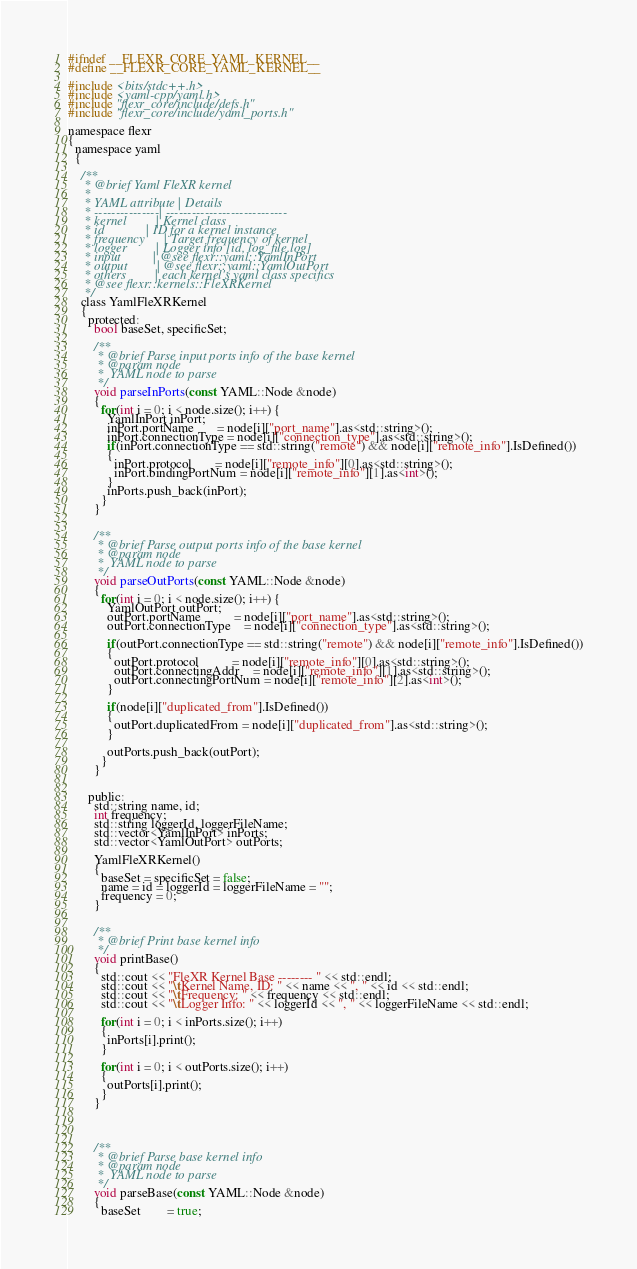<code> <loc_0><loc_0><loc_500><loc_500><_C_>#ifndef __FLEXR_CORE_YAML_KERNEL__
#define __FLEXR_CORE_YAML_KERNEL__

#include <bits/stdc++.h>
#include <yaml-cpp/yaml.h>
#include "flexr_core/include/defs.h"
#include "flexr_core/include/yaml_ports.h"

namespace flexr
{
  namespace yaml
  {

    /**
     * @brief Yaml FleXR kernel
     *
     * YAML attribute | Details
     * ---------------| ----------------------------
     * kernel         | Kernel class
     * id             | ID for a kernel instance
     * frequency      | Target frequency of kernel
     * logger         | Logger info [id, log_file.log]
     * input          | @see flexr::yaml::YamlInPort
     * output         | @see flexr::yaml::YamlOutPort
     * others         | each kernel's yaml class specifics
     * @see flexr::kernels::FleXRKernel
     */
    class YamlFleXRKernel
    {
      protected:
        bool baseSet, specificSet;

        /**
         * @brief Parse input ports info of the base kernel
         * @param node
         *  YAML node to parse
         */
        void parseInPorts(const YAML::Node &node)
        {
          for(int i = 0; i < node.size(); i++) {
            YamlInPort inPort;
            inPort.portName       = node[i]["port_name"].as<std::string>();
            inPort.connectionType = node[i]["connection_type"].as<std::string>();
            if(inPort.connectionType == std::string("remote") && node[i]["remote_info"].IsDefined())
            {
              inPort.protocol       = node[i]["remote_info"][0].as<std::string>();
              inPort.bindingPortNum = node[i]["remote_info"][1].as<int>();
            }
            inPorts.push_back(inPort);
          }
        }


        /**
         * @brief Parse output ports info of the base kernel
         * @param node
         *  YAML node to parse
         */
        void parseOutPorts(const YAML::Node &node)
        {
          for(int i = 0; i < node.size(); i++) {
            YamlOutPort outPort;
            outPort.portName          = node[i]["port_name"].as<std::string>();
            outPort.connectionType    = node[i]["connection_type"].as<std::string>();

            if(outPort.connectionType == std::string("remote") && node[i]["remote_info"].IsDefined())
            {
              outPort.protocol          = node[i]["remote_info"][0].as<std::string>();
              outPort.connectingAddr    = node[i]["remote_info"][1].as<std::string>();
              outPort.connectingPortNum = node[i]["remote_info"][2].as<int>();
            }

            if(node[i]["duplicated_from"].IsDefined())
            {
              outPort.duplicatedFrom = node[i]["duplicated_from"].as<std::string>();
            }

            outPorts.push_back(outPort);
          }
        }


      public:
        std::string name, id;
        int frequency;
        std::string loggerId, loggerFileName;
        std::vector<YamlInPort> inPorts;
        std::vector<YamlOutPort> outPorts;

        YamlFleXRKernel()
        {
          baseSet = specificSet = false;
          name = id = loggerId = loggerFileName = "";
          frequency = 0;
        }


        /**
         * @brief Print base kernel info
         */
        void printBase()
        {
          std::cout << "FleXR Kernel Base -------- " << std::endl;
          std::cout << "\tKernel Name, ID: " << name << ", " << id << std::endl;
          std::cout << "\tFrequency: " << frequency << std::endl;
          std::cout << "\tLogger Info: " << loggerId << ", " << loggerFileName << std::endl;

          for(int i = 0; i < inPorts.size(); i++)
          {
            inPorts[i].print();
          }

          for(int i = 0; i < outPorts.size(); i++)
          {
            outPorts[i].print();
          }
        }




        /**
         * @brief Parse base kernel info
         * @param node
         *  YAML node to parse
         */
        void parseBase(const YAML::Node &node)
        {
          baseSet        = true;</code> 